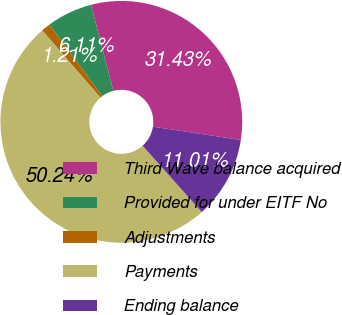Convert chart to OTSL. <chart><loc_0><loc_0><loc_500><loc_500><pie_chart><fcel>Third Wave balance acquired<fcel>Provided for under EITF No<fcel>Adjustments<fcel>Payments<fcel>Ending balance<nl><fcel>31.43%<fcel>6.11%<fcel>1.21%<fcel>50.24%<fcel>11.01%<nl></chart> 